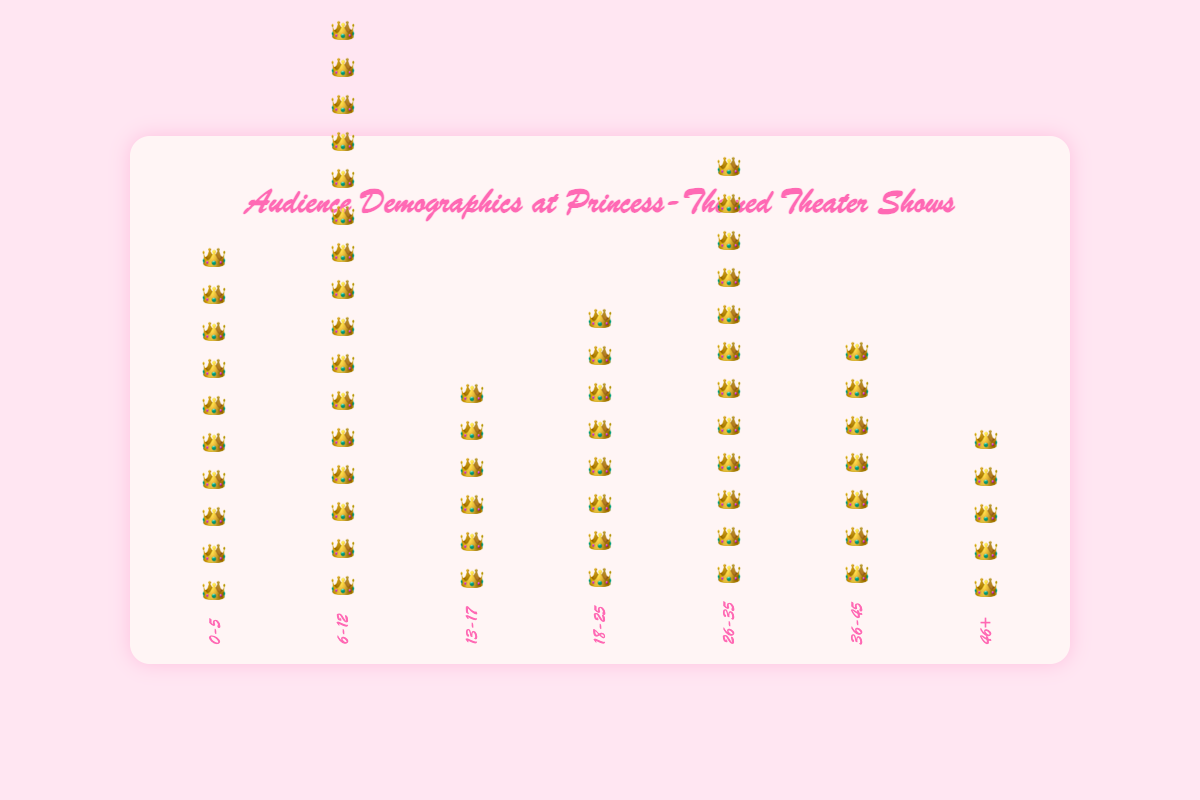Who is the primary audience age group for princess-themed theater shows based on the chart? Looking at the bars in the isotype plot, the group with the tallest bar has the greatest audience count. The 6-12 age group has the tallest bar, indicating the largest number of audience members.
Answer: 6-12 Which age group has the fewest audience members? By examining the bars in the isotype plot, the shortest bar represents the age group with the fewest audience members. The 46+ age group has the shortest bar.
Answer: 46+ How does the number of audience members in the 26-35 age group compare to the number in the 36-45 age group? The 26-35 age group has a taller bar compared to the 36-45 age group, indicating more audience members. Specifically, the 26-35 age group has 60 audience members, while the 36-45 age group has 35 members.
Answer: More in 26-35 What is the total number of audience members in the 0-5 and 6-12 age groups combined? Sum the counts of the 0-5 and 6-12 age groups: 50 (0-5) + 80 (6-12) = 130.
Answer: 130 Which age groups have fewer than 40 audience members? Identify bars with fewer crowd icons representing audience counts less than 40. These are the groups 13-17 (30), 36-45 (35), and 46+ (25).
Answer: 13-17, 36-45, 46+ What percentage of the total audience do the 18-25 age group represent? First, calculate the total number of audience members across all age groups: 50 + 80 + 30 + 40 + 60 + 35 + 25 = 320. Then, divide the 18-25 age group's count by the total and multiply by 100: (40 / 320) * 100 = 12.5%.
Answer: 12.5% What is the difference in audience size between the 0-5 and 26-35 age groups? Subtract the audience count of the 0-5 age group from the 26-35 age group: 60 - 50 = 10.
Answer: 10 Which age group falls exactly halfway in audience size between the 0-5 and 6-12 age groups? The 0-5 age group has 50 audience members and the 6-12 group has 80. The halfway point between these counts is: (50+80)/2 = 65. The 26-35 age group, with 60 members, is closest to this number.
Answer: 26-35 